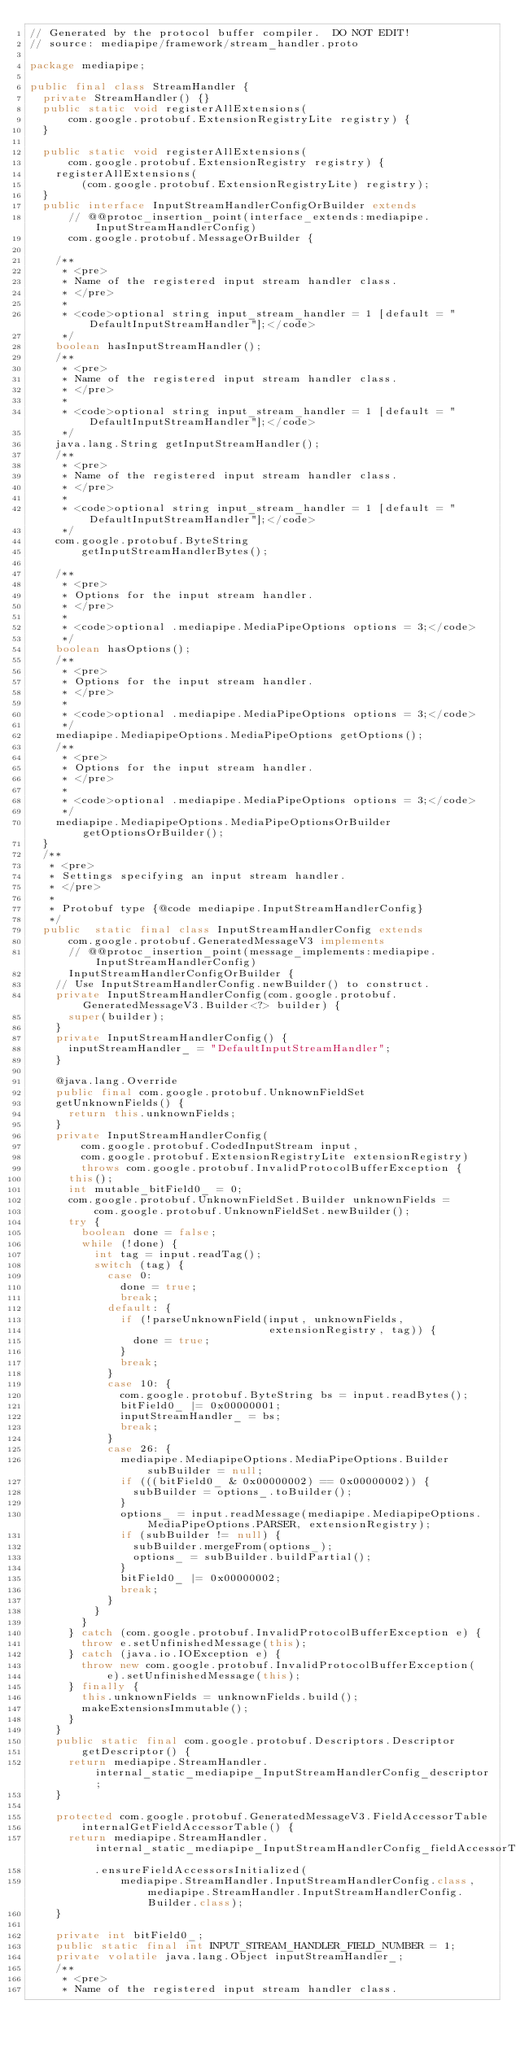Convert code to text. <code><loc_0><loc_0><loc_500><loc_500><_Java_>// Generated by the protocol buffer compiler.  DO NOT EDIT!
// source: mediapipe/framework/stream_handler.proto

package mediapipe;

public final class StreamHandler {
  private StreamHandler() {}
  public static void registerAllExtensions(
      com.google.protobuf.ExtensionRegistryLite registry) {
  }

  public static void registerAllExtensions(
      com.google.protobuf.ExtensionRegistry registry) {
    registerAllExtensions(
        (com.google.protobuf.ExtensionRegistryLite) registry);
  }
  public interface InputStreamHandlerConfigOrBuilder extends
      // @@protoc_insertion_point(interface_extends:mediapipe.InputStreamHandlerConfig)
      com.google.protobuf.MessageOrBuilder {

    /**
     * <pre>
     * Name of the registered input stream handler class.
     * </pre>
     *
     * <code>optional string input_stream_handler = 1 [default = "DefaultInputStreamHandler"];</code>
     */
    boolean hasInputStreamHandler();
    /**
     * <pre>
     * Name of the registered input stream handler class.
     * </pre>
     *
     * <code>optional string input_stream_handler = 1 [default = "DefaultInputStreamHandler"];</code>
     */
    java.lang.String getInputStreamHandler();
    /**
     * <pre>
     * Name of the registered input stream handler class.
     * </pre>
     *
     * <code>optional string input_stream_handler = 1 [default = "DefaultInputStreamHandler"];</code>
     */
    com.google.protobuf.ByteString
        getInputStreamHandlerBytes();

    /**
     * <pre>
     * Options for the input stream handler.
     * </pre>
     *
     * <code>optional .mediapipe.MediaPipeOptions options = 3;</code>
     */
    boolean hasOptions();
    /**
     * <pre>
     * Options for the input stream handler.
     * </pre>
     *
     * <code>optional .mediapipe.MediaPipeOptions options = 3;</code>
     */
    mediapipe.MediapipeOptions.MediaPipeOptions getOptions();
    /**
     * <pre>
     * Options for the input stream handler.
     * </pre>
     *
     * <code>optional .mediapipe.MediaPipeOptions options = 3;</code>
     */
    mediapipe.MediapipeOptions.MediaPipeOptionsOrBuilder getOptionsOrBuilder();
  }
  /**
   * <pre>
   * Settings specifying an input stream handler.
   * </pre>
   *
   * Protobuf type {@code mediapipe.InputStreamHandlerConfig}
   */
  public  static final class InputStreamHandlerConfig extends
      com.google.protobuf.GeneratedMessageV3 implements
      // @@protoc_insertion_point(message_implements:mediapipe.InputStreamHandlerConfig)
      InputStreamHandlerConfigOrBuilder {
    // Use InputStreamHandlerConfig.newBuilder() to construct.
    private InputStreamHandlerConfig(com.google.protobuf.GeneratedMessageV3.Builder<?> builder) {
      super(builder);
    }
    private InputStreamHandlerConfig() {
      inputStreamHandler_ = "DefaultInputStreamHandler";
    }

    @java.lang.Override
    public final com.google.protobuf.UnknownFieldSet
    getUnknownFields() {
      return this.unknownFields;
    }
    private InputStreamHandlerConfig(
        com.google.protobuf.CodedInputStream input,
        com.google.protobuf.ExtensionRegistryLite extensionRegistry)
        throws com.google.protobuf.InvalidProtocolBufferException {
      this();
      int mutable_bitField0_ = 0;
      com.google.protobuf.UnknownFieldSet.Builder unknownFields =
          com.google.protobuf.UnknownFieldSet.newBuilder();
      try {
        boolean done = false;
        while (!done) {
          int tag = input.readTag();
          switch (tag) {
            case 0:
              done = true;
              break;
            default: {
              if (!parseUnknownField(input, unknownFields,
                                     extensionRegistry, tag)) {
                done = true;
              }
              break;
            }
            case 10: {
              com.google.protobuf.ByteString bs = input.readBytes();
              bitField0_ |= 0x00000001;
              inputStreamHandler_ = bs;
              break;
            }
            case 26: {
              mediapipe.MediapipeOptions.MediaPipeOptions.Builder subBuilder = null;
              if (((bitField0_ & 0x00000002) == 0x00000002)) {
                subBuilder = options_.toBuilder();
              }
              options_ = input.readMessage(mediapipe.MediapipeOptions.MediaPipeOptions.PARSER, extensionRegistry);
              if (subBuilder != null) {
                subBuilder.mergeFrom(options_);
                options_ = subBuilder.buildPartial();
              }
              bitField0_ |= 0x00000002;
              break;
            }
          }
        }
      } catch (com.google.protobuf.InvalidProtocolBufferException e) {
        throw e.setUnfinishedMessage(this);
      } catch (java.io.IOException e) {
        throw new com.google.protobuf.InvalidProtocolBufferException(
            e).setUnfinishedMessage(this);
      } finally {
        this.unknownFields = unknownFields.build();
        makeExtensionsImmutable();
      }
    }
    public static final com.google.protobuf.Descriptors.Descriptor
        getDescriptor() {
      return mediapipe.StreamHandler.internal_static_mediapipe_InputStreamHandlerConfig_descriptor;
    }

    protected com.google.protobuf.GeneratedMessageV3.FieldAccessorTable
        internalGetFieldAccessorTable() {
      return mediapipe.StreamHandler.internal_static_mediapipe_InputStreamHandlerConfig_fieldAccessorTable
          .ensureFieldAccessorsInitialized(
              mediapipe.StreamHandler.InputStreamHandlerConfig.class, mediapipe.StreamHandler.InputStreamHandlerConfig.Builder.class);
    }

    private int bitField0_;
    public static final int INPUT_STREAM_HANDLER_FIELD_NUMBER = 1;
    private volatile java.lang.Object inputStreamHandler_;
    /**
     * <pre>
     * Name of the registered input stream handler class.</code> 